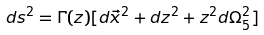Convert formula to latex. <formula><loc_0><loc_0><loc_500><loc_500>d s ^ { 2 } = \Gamma ( z ) [ d \vec { x } ^ { 2 } + d z ^ { 2 } + z ^ { 2 } d \Omega _ { 5 } ^ { 2 } ]</formula> 